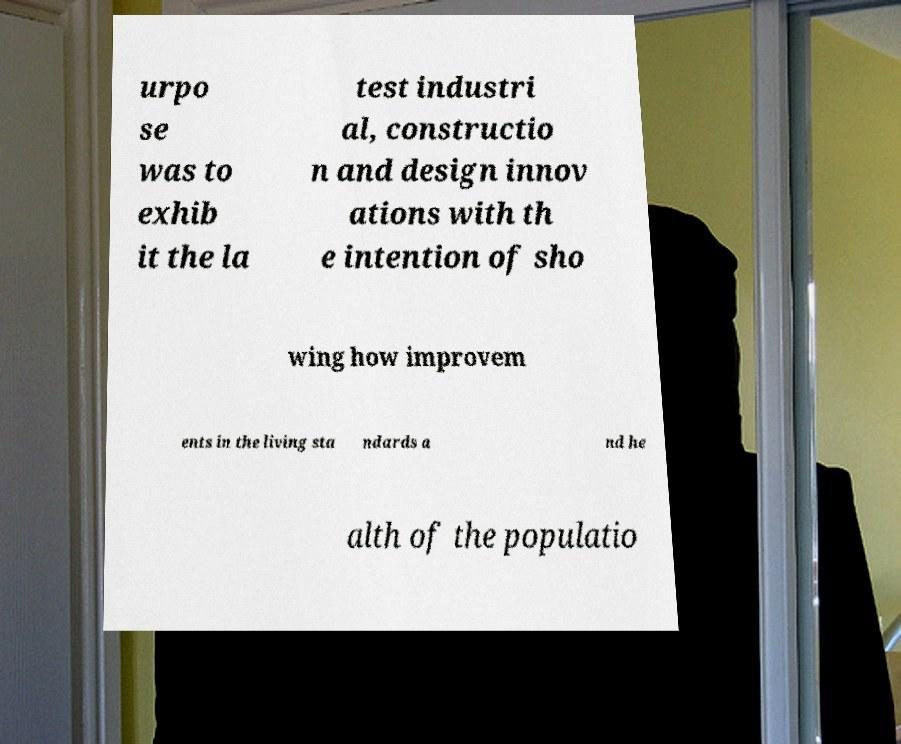I need the written content from this picture converted into text. Can you do that? urpo se was to exhib it the la test industri al, constructio n and design innov ations with th e intention of sho wing how improvem ents in the living sta ndards a nd he alth of the populatio 